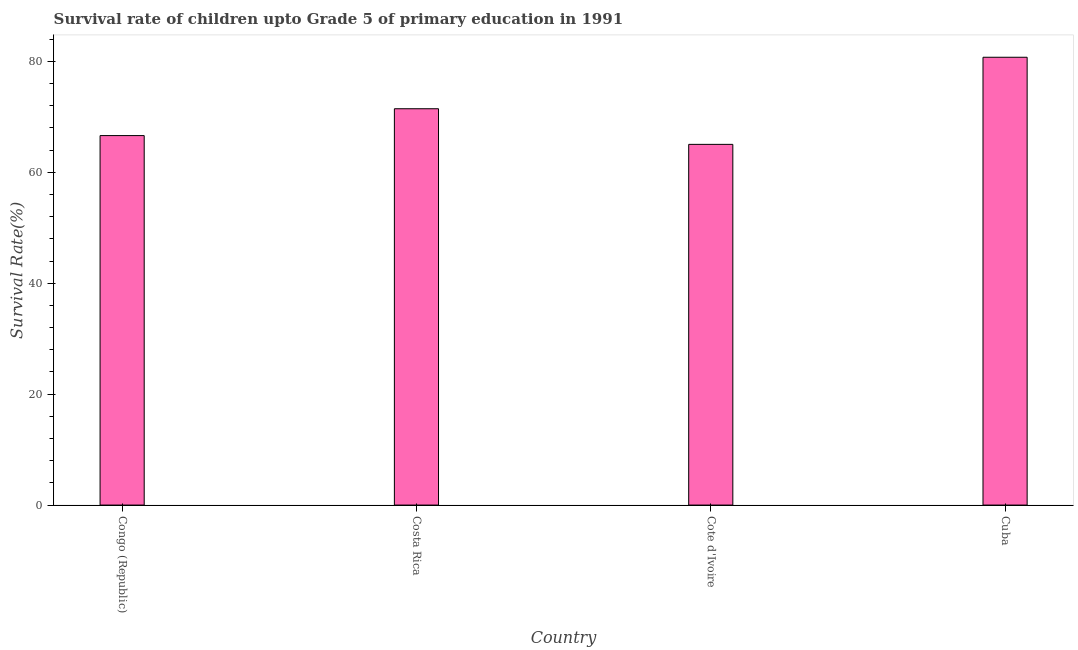Does the graph contain any zero values?
Make the answer very short. No. Does the graph contain grids?
Keep it short and to the point. No. What is the title of the graph?
Your answer should be compact. Survival rate of children upto Grade 5 of primary education in 1991 . What is the label or title of the X-axis?
Your answer should be compact. Country. What is the label or title of the Y-axis?
Provide a short and direct response. Survival Rate(%). What is the survival rate in Congo (Republic)?
Your response must be concise. 66.62. Across all countries, what is the maximum survival rate?
Your answer should be compact. 80.74. Across all countries, what is the minimum survival rate?
Keep it short and to the point. 65.03. In which country was the survival rate maximum?
Ensure brevity in your answer.  Cuba. In which country was the survival rate minimum?
Offer a terse response. Cote d'Ivoire. What is the sum of the survival rate?
Provide a short and direct response. 283.84. What is the difference between the survival rate in Cote d'Ivoire and Cuba?
Ensure brevity in your answer.  -15.7. What is the average survival rate per country?
Provide a short and direct response. 70.96. What is the median survival rate?
Offer a very short reply. 69.04. In how many countries, is the survival rate greater than 68 %?
Your response must be concise. 2. Is the difference between the survival rate in Costa Rica and Cuba greater than the difference between any two countries?
Keep it short and to the point. No. What is the difference between the highest and the second highest survival rate?
Provide a short and direct response. 9.28. Are all the bars in the graph horizontal?
Your answer should be very brief. No. How many countries are there in the graph?
Offer a very short reply. 4. What is the difference between two consecutive major ticks on the Y-axis?
Your answer should be very brief. 20. Are the values on the major ticks of Y-axis written in scientific E-notation?
Offer a terse response. No. What is the Survival Rate(%) in Congo (Republic)?
Your answer should be compact. 66.62. What is the Survival Rate(%) in Costa Rica?
Your answer should be very brief. 71.46. What is the Survival Rate(%) in Cote d'Ivoire?
Offer a very short reply. 65.03. What is the Survival Rate(%) in Cuba?
Make the answer very short. 80.74. What is the difference between the Survival Rate(%) in Congo (Republic) and Costa Rica?
Provide a succinct answer. -4.84. What is the difference between the Survival Rate(%) in Congo (Republic) and Cote d'Ivoire?
Make the answer very short. 1.58. What is the difference between the Survival Rate(%) in Congo (Republic) and Cuba?
Your answer should be compact. -14.12. What is the difference between the Survival Rate(%) in Costa Rica and Cote d'Ivoire?
Keep it short and to the point. 6.42. What is the difference between the Survival Rate(%) in Costa Rica and Cuba?
Your answer should be very brief. -9.28. What is the difference between the Survival Rate(%) in Cote d'Ivoire and Cuba?
Provide a short and direct response. -15.7. What is the ratio of the Survival Rate(%) in Congo (Republic) to that in Costa Rica?
Your response must be concise. 0.93. What is the ratio of the Survival Rate(%) in Congo (Republic) to that in Cote d'Ivoire?
Ensure brevity in your answer.  1.02. What is the ratio of the Survival Rate(%) in Congo (Republic) to that in Cuba?
Your response must be concise. 0.82. What is the ratio of the Survival Rate(%) in Costa Rica to that in Cote d'Ivoire?
Give a very brief answer. 1.1. What is the ratio of the Survival Rate(%) in Costa Rica to that in Cuba?
Your response must be concise. 0.89. What is the ratio of the Survival Rate(%) in Cote d'Ivoire to that in Cuba?
Your answer should be compact. 0.81. 